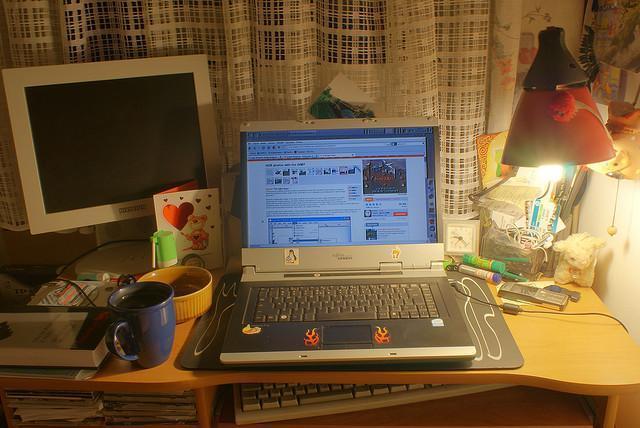How many screens are on?
Give a very brief answer. 1. How many keyboards are visible?
Give a very brief answer. 2. 